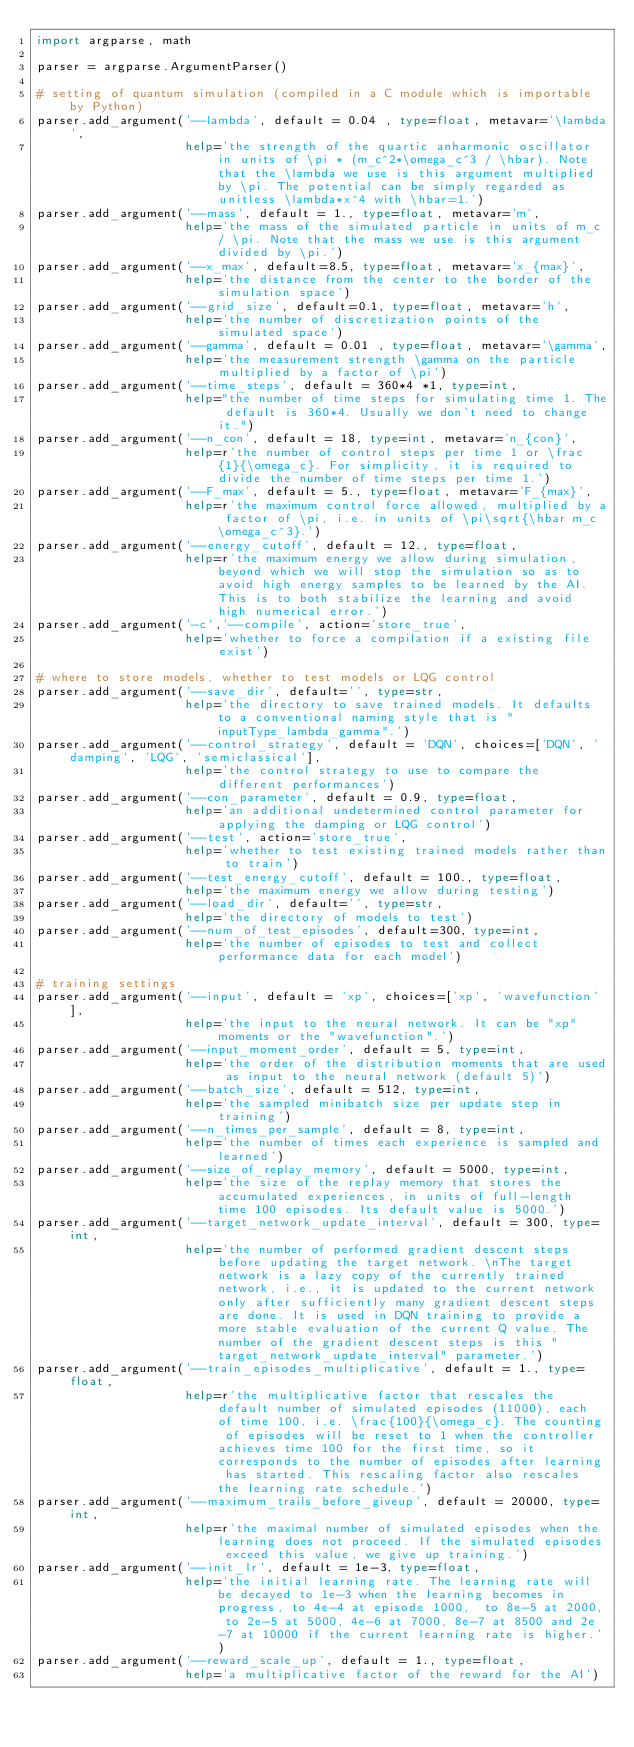<code> <loc_0><loc_0><loc_500><loc_500><_Python_>import argparse, math

parser = argparse.ArgumentParser()

# setting of quantum simulation (compiled in a C module which is importable by Python)
parser.add_argument('--lambda', default = 0.04 , type=float, metavar='\lambda',
                    help='the strength of the quartic anharmonic oscillator in units of \pi * (m_c^2*\omega_c^3 / \hbar). Note that the \lambda we use is this argument multiplied by \pi. The potential can be simply regarded as unitless \lambda*x^4 with \hbar=1.')
parser.add_argument('--mass', default = 1., type=float, metavar='m',
                    help='the mass of the simulated particle in units of m_c / \pi. Note that the mass we use is this argument divided by \pi.')
parser.add_argument('--x_max', default=8.5, type=float, metavar='x_{max}',
                    help='the distance from the center to the border of the simulation space')
parser.add_argument('--grid_size', default=0.1, type=float, metavar='h',
                    help='the number of discretization points of the simulated space')
parser.add_argument('--gamma', default = 0.01 , type=float, metavar='\gamma',
                    help='the measurement strength \gamma on the particle multiplied by a factor of \pi')
parser.add_argument('--time_steps', default = 360*4 *1, type=int,
                    help="the number of time steps for simulating time 1. The default is 360*4. Usually we don't need to change it.")
parser.add_argument('--n_con', default = 18, type=int, metavar='n_{con}',
                    help=r'the number of control steps per time 1 or \frac{1}{\omega_c}. For simplicity, it is required to divide the number of time steps per time 1.')
parser.add_argument('--F_max', default = 5., type=float, metavar='F_{max}',
                    help=r'the maximum control force allowed, multiplied by a factor of \pi, i.e. in units of \pi\sqrt{\hbar m_c \omega_c^3}.')
parser.add_argument('--energy_cutoff', default = 12., type=float,
                    help=r'the maximum energy we allow during simulation, beyond which we will stop the simulation so as to avoid high energy samples to be learned by the AI. This is to both stabilize the learning and avoid high numerical error.')
parser.add_argument('-c','--compile', action='store_true',
                    help='whether to force a compilation if a existing file exist')

# where to store models, whether to test models or LQG control
parser.add_argument('--save_dir', default='', type=str,
                    help='the directory to save trained models. It defaults to a conventional naming style that is "inputType_lambda_gamma".')
parser.add_argument('--control_strategy', default = 'DQN', choices=['DQN', 'damping', 'LQG', 'semiclassical'],
                    help='the control strategy to use to compare the different performances')
parser.add_argument('--con_parameter', default = 0.9, type=float,
                    help='an additional undetermined control parameter for applying the damping or LQG control')
parser.add_argument('--test', action='store_true',
                    help='whether to test existing trained models rather than to train')
parser.add_argument('--test_energy_cutoff', default = 100., type=float,
                    help='the maximum energy we allow during testing')
parser.add_argument('--load_dir', default='', type=str,
                    help='the directory of models to test')
parser.add_argument('--num_of_test_episodes', default=300, type=int,
                    help='the number of episodes to test and collect performance data for each model')

# training settings
parser.add_argument('--input', default = 'xp', choices=['xp', 'wavefunction'],
                    help='the input to the neural network. It can be "xp" moments or the "wavefunction".')
parser.add_argument('--input_moment_order', default = 5, type=int,
                    help='the order of the distribution moments that are used as input to the neural network (default 5)')
parser.add_argument('--batch_size', default = 512, type=int,
                    help='the sampled minibatch size per update step in training')
parser.add_argument('--n_times_per_sample', default = 8, type=int,
                    help='the number of times each experience is sampled and learned')
parser.add_argument('--size_of_replay_memory', default = 5000, type=int,
                    help='the size of the replay memory that stores the accumulated experiences, in units of full-length time 100 episodes. Its default value is 5000.')
parser.add_argument('--target_network_update_interval', default = 300, type=int,
                    help='the number of performed gradient descent steps before updating the target network. \nThe target network is a lazy copy of the currently trained network, i.e., it is updated to the current network only after sufficiently many gradient descent steps are done. It is used in DQN training to provide a more stable evaluation of the current Q value. The number of the gradient descent steps is this "target_network_update_interval" parameter.')
parser.add_argument('--train_episodes_multiplicative', default = 1., type=float,
                    help=r'the multiplicative factor that rescales the default number of simulated episodes (11000), each of time 100, i.e. \frac{100}{\omega_c}. The counting of episodes will be reset to 1 when the controller achieves time 100 for the first time, so it corresponds to the number of episodes after learning has started. This rescaling factor also rescales the learning rate schedule.')
parser.add_argument('--maximum_trails_before_giveup', default = 20000, type=int,
                    help=r'the maximal number of simulated episodes when the learning does not proceed. If the simulated episodes exceed this value, we give up training.')
parser.add_argument('--init_lr', default = 1e-3, type=float,
                    help='the initial learning rate. The learning rate will be decayed to 1e-3 when the learning becomes in progress, to 4e-4 at episode 1000,  to 8e-5 at 2000, to 2e-5 at 5000, 4e-6 at 7000, 8e-7 at 8500 and 2e-7 at 10000 if the current learning rate is higher.')
parser.add_argument('--reward_scale_up', default = 1., type=float,
                    help='a multiplicative factor of the reward for the AI')</code> 